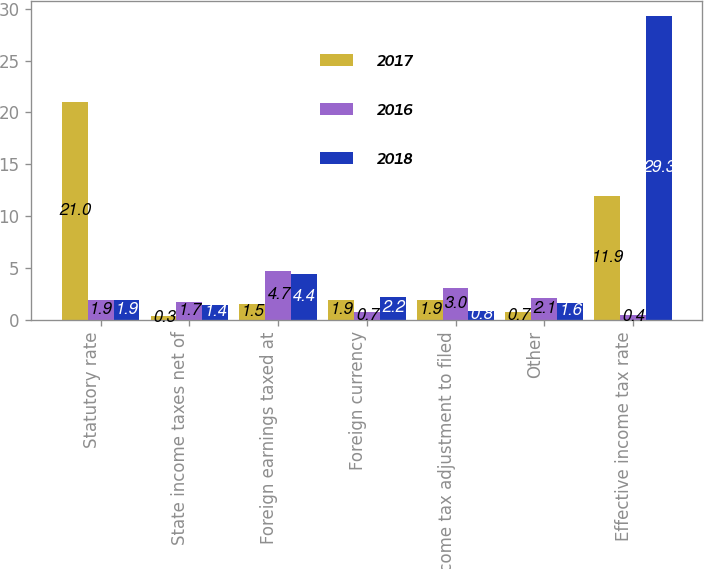Convert chart. <chart><loc_0><loc_0><loc_500><loc_500><stacked_bar_chart><ecel><fcel>Statutory rate<fcel>State income taxes net of<fcel>Foreign earnings taxed at<fcel>Foreign currency<fcel>Income tax adjustment to filed<fcel>Other<fcel>Effective income tax rate<nl><fcel>2017<fcel>21<fcel>0.3<fcel>1.5<fcel>1.9<fcel>1.9<fcel>0.7<fcel>11.9<nl><fcel>2016<fcel>1.9<fcel>1.7<fcel>4.7<fcel>0.7<fcel>3<fcel>2.1<fcel>0.4<nl><fcel>2018<fcel>1.9<fcel>1.4<fcel>4.4<fcel>2.2<fcel>0.8<fcel>1.6<fcel>29.3<nl></chart> 